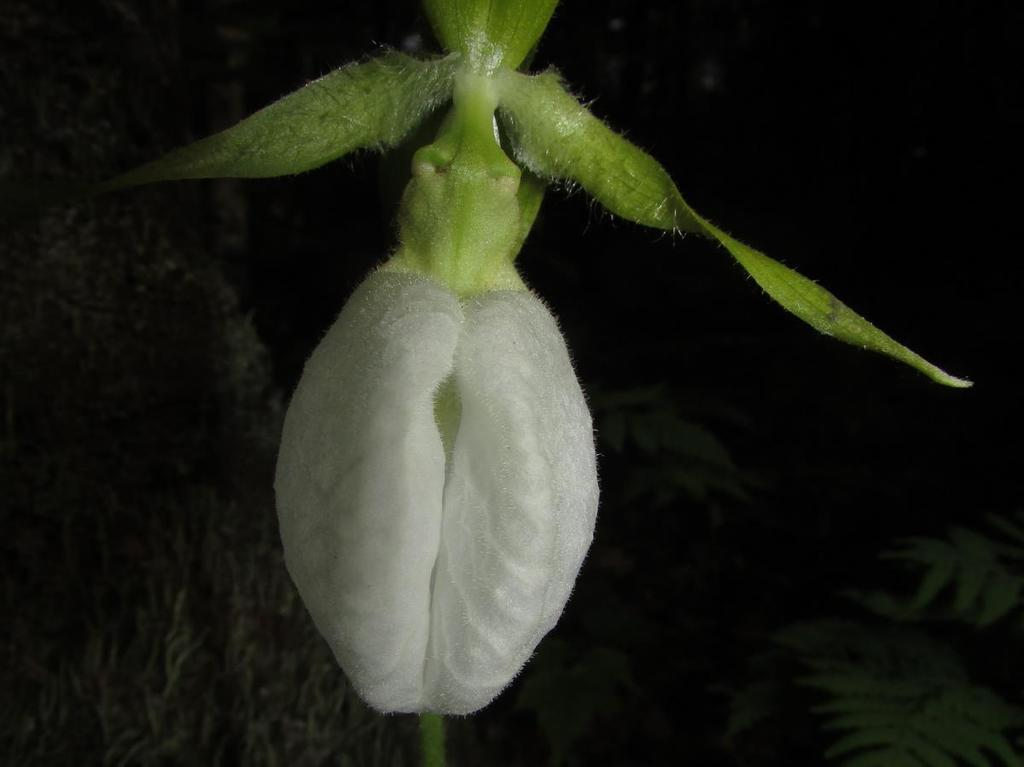What is the main subject of the picture? The main subject of the picture is a flower. Can you describe the flower's structure? The flower has a stem. What is attached to the stem? The stem has leafs. What type of cracker is being used to wage war on the flower's throat in the image? There is no cracker, war, or throat present in the image; it features a flower with a stem and leafs. 